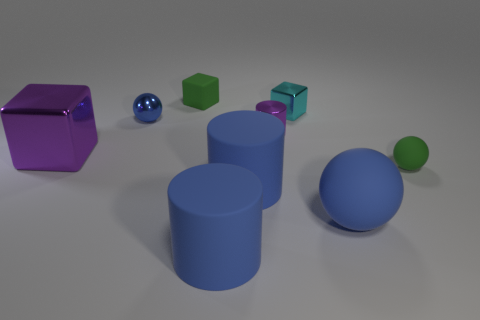What are the different colors of the objects presented here, and what might they signify? The image showcases objects in various colors: violet, cyan, green, blue, and possibly metallic shades. These colors could signify diversity or categorization, possibly representing different groups, types, or characteristics in a symbolic manner. 